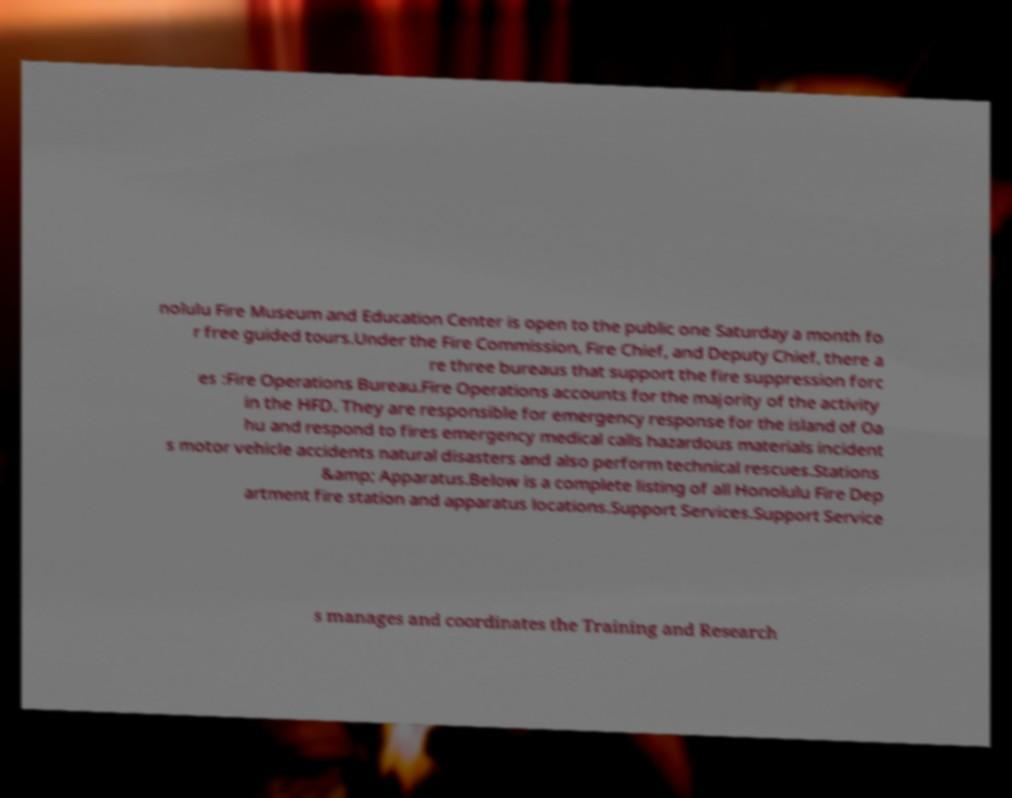Could you extract and type out the text from this image? nolulu Fire Museum and Education Center is open to the public one Saturday a month fo r free guided tours.Under the Fire Commission, Fire Chief, and Deputy Chief, there a re three bureaus that support the fire suppression forc es :Fire Operations Bureau.Fire Operations accounts for the majority of the activity in the HFD. They are responsible for emergency response for the island of Oa hu and respond to fires emergency medical calls hazardous materials incident s motor vehicle accidents natural disasters and also perform technical rescues.Stations &amp; Apparatus.Below is a complete listing of all Honolulu Fire Dep artment fire station and apparatus locations.Support Services.Support Service s manages and coordinates the Training and Research 